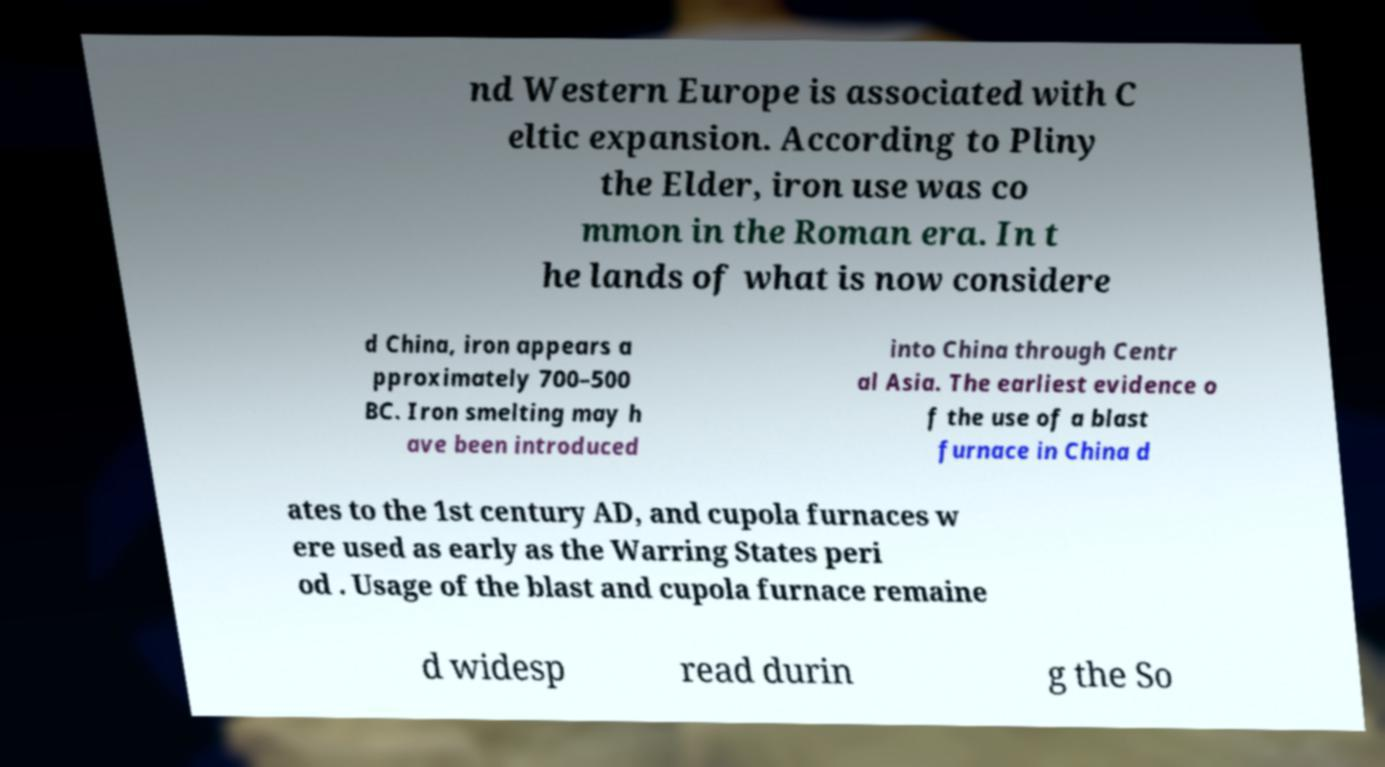Can you read and provide the text displayed in the image?This photo seems to have some interesting text. Can you extract and type it out for me? nd Western Europe is associated with C eltic expansion. According to Pliny the Elder, iron use was co mmon in the Roman era. In t he lands of what is now considere d China, iron appears a pproximately 700–500 BC. Iron smelting may h ave been introduced into China through Centr al Asia. The earliest evidence o f the use of a blast furnace in China d ates to the 1st century AD, and cupola furnaces w ere used as early as the Warring States peri od . Usage of the blast and cupola furnace remaine d widesp read durin g the So 